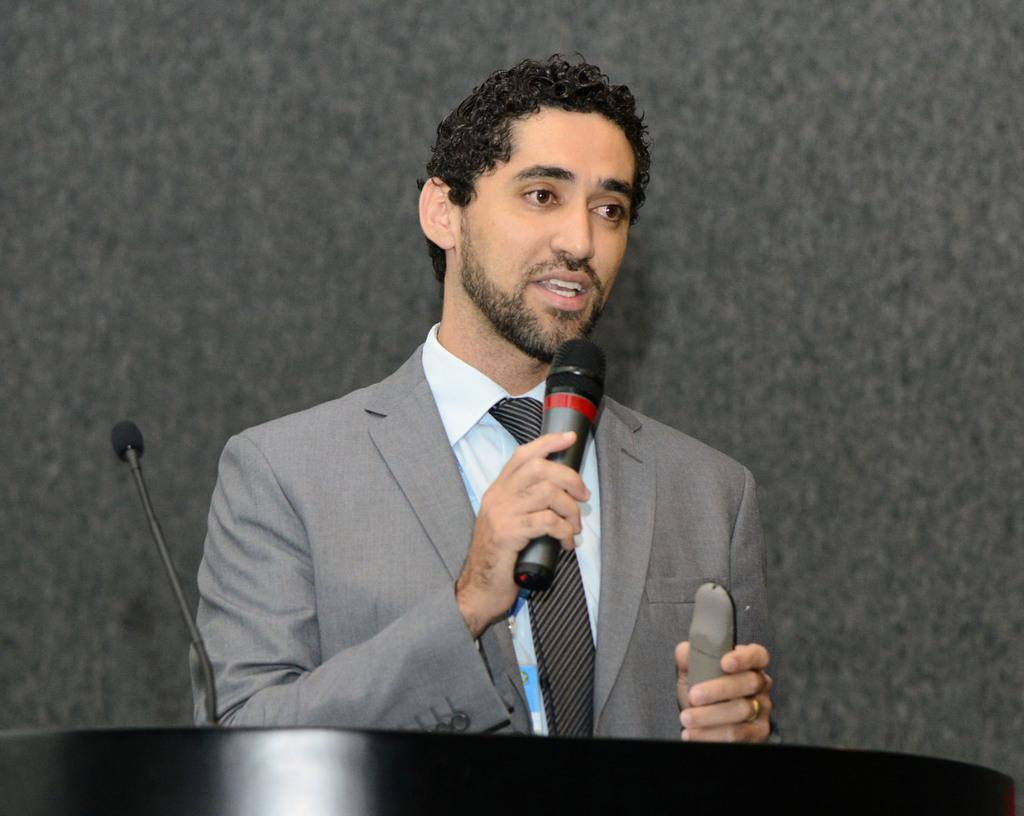What is the main subject of the image? There is a man in the image. What is the man holding in his hand? The man is holding a microphone in his hand. What is the man doing with the microphone? The man is talking while holding the microphone. What type of boat can be seen in the image? There is no boat present in the image; it features a man holding a microphone and talking. What kind of apparatus is the man using to communicate with the potato in the image? There is no potato present in the image, and the man is not using any apparatus to communicate with a potato. 